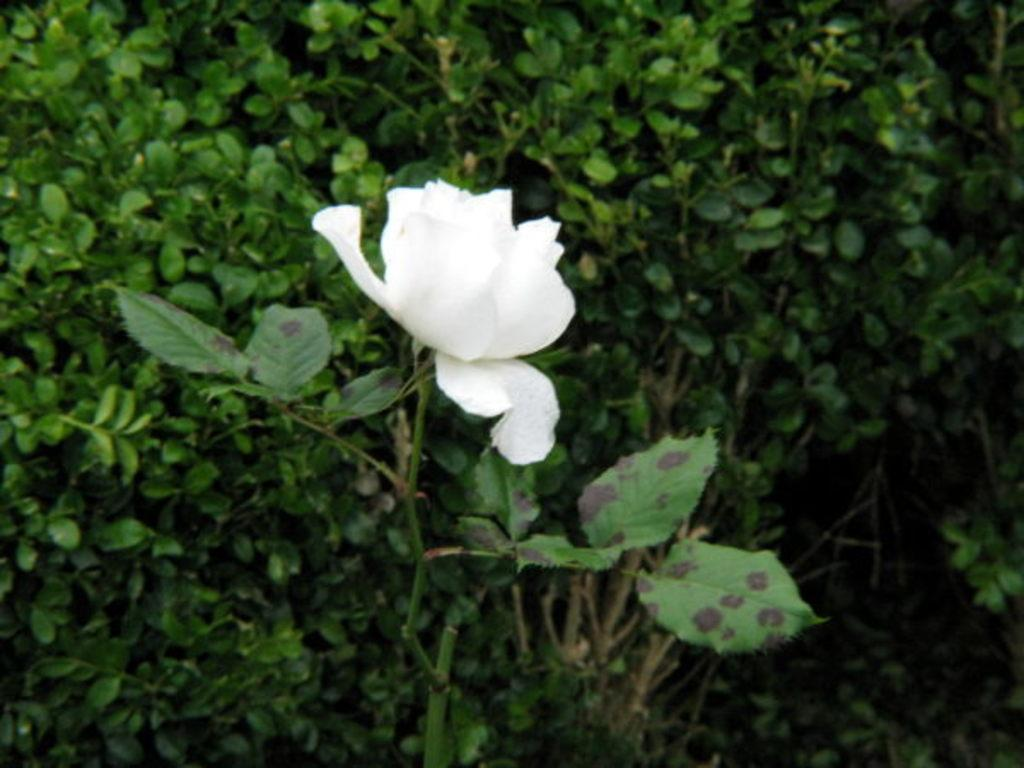What type of flower can be seen on a plant in the image? There is a white flower on a plant in the image. Are there any other plants visible in the image? Yes, there are other plants visible in the image. What type of brush is being used to take action on the plants in the image? There is no brush or action being taken on the plants in the image; it simply shows the plants and the white flower. 